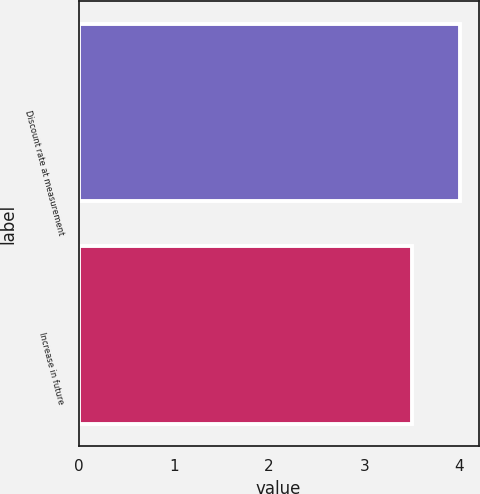<chart> <loc_0><loc_0><loc_500><loc_500><bar_chart><fcel>Discount rate at measurement<fcel>Increase in future<nl><fcel>4<fcel>3.5<nl></chart> 